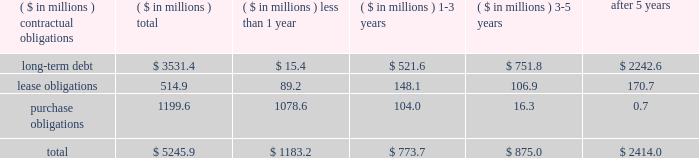The liabilities recognized as a result of consolidating these entities do not represent additional claims on the general assets of the company .
The creditors of these entities have claims only on the assets of the specific variable interest entities to which they have advanced credit .
Obligations and commitments as part of its ongoing operations , the company enters into arrangements that obligate the company to make future payments under contracts such as debt agreements , lease agreements , and unconditional purchase obligations ( i.e. , obligations to transfer funds in the future for fixed or minimum quantities of goods or services at fixed or minimum prices , such as 201ctake-or-pay 201d contracts ) .
The unconditional purchase obligation arrangements are entered into by the company in its normal course of business in order to ensure adequate levels of sourced product are available to the company .
Capital lease and debt obligations , which totaled $ 3.5 billion at may 25 , 2008 , are currently recognized as liabilities in the company 2019s consolidated balance sheet .
Operating lease obligations and unconditional purchase obligations , which totaled $ 1.7 billion at may 25 , 2008 , are not recognized as liabilities in the company 2019s consolidated balance sheet , in accordance with generally accepted accounting principles .
A summary of the company 2019s contractual obligations at the end of fiscal 2008 was as follows ( including obligations of discontinued operations ) : .
The purchase obligations noted in the table above do not reflect approximately $ 374 million of open purchase orders , some of which are not legally binding .
These purchase orders are settlable in the ordinary course of business in less than one year .
The company is also contractually obligated to pay interest on its long-term debt obligations .
The weighted average interest rate of the long-term debt obligations outstanding as of may 25 , 2008 was approximately 7.2% ( 7.2 % ) .
The company consolidates the assets and liabilities of certain entities from which it leases corporate aircraft .
These entities have been determined to be variable interest entities and the company has been determined to be the primary beneficiary of these entities .
The amounts reflected in contractual obligations of long-term debt , in the table above , include $ 54 million of liabilities of these variable interest entities to the creditors of such entities .
The long-term debt recognized as a result of consolidating these entities does not represent additional claims on the general assets of the company .
The creditors of these entities have claims only on the assets of the specific variable interest entities .
As of may 25 , 2008 , the company was obligated to make rental payments of $ 67 million to the variable interest entities , of which $ 7 million is due in less than one year , $ 13 million is due in one to three years , and $ 47 million is due in three to five years .
Such amounts are not reflected in the table , above .
As part of its ongoing operations , the company also enters into arrangements that obligate the company to make future cash payments only upon the occurrence of a future event ( e.g. , guarantee debt or lease payments of a third party should the third party be unable to perform ) .
In accordance with generally accepted accounting principles , the following commercial commitments are not recognized as liabilities in the company 2019s .
What percentage of total contractual obligations at the end of fiscal 2008 was due to lease obligations? 
Computations: (514.9 / 5245.9)
Answer: 0.09815. 